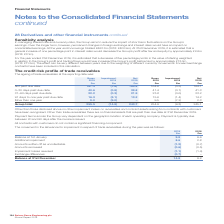According to Spirax Sarco Engineering Plc's financial document, How do payment terms across the Group vary? dependent on the geographic location of each operating company. The document states: "Payment terms across the Group vary dependent on the geographic location of each operating company. Payment is typically due between 20 and 90 days af..." Also, When is payment typically due for trade receivables? between 20 and 90 days after the invoice is issued. The document states: "each operating company. Payment is typically due between 20 and 90 days after the invoice is issued...." Also, For which years was the movement in the allowance for impairment in respect of trade receivables during the year recorded? The document shows two values: 2019 and 2018. From the document: "Spirax-Sarco Engineering plc Annual Report 2019 ngs. At the year end borrowings totalled £463.7m (2018: £422.9m). At 31st December 2019, it is estimat..." Additionally, In which year was the balance at 1st January larger? According to the financial document, 2019. The relevant text states: "Spirax-Sarco Engineering plc Annual Report 2019..." Also, can you calculate: What was the change in the balance at 31st December in 2019 from 2018? Based on the calculation: 14.8-9.8, the result is 5 (in millions). This is based on the information: "2018 £m Balance at 1st January 9.8 9.6 Additional impairment 8.6 2.8 Amounts written off as uncollectable (1.2) (0.7) Amounts recovere ange differences (0.7) – Balance at 31st December 14.8 9.8..." The key data points involved are: 14.8, 9.8. Also, can you calculate: What was the percentage change in the balance at 31st December in 2019 from 2018? To answer this question, I need to perform calculations using the financial data. The calculation is: (14.8-9.8)/9.8, which equals 51.02 (percentage). This is based on the information: "2018 £m Balance at 1st January 9.8 9.6 Additional impairment 8.6 2.8 Amounts written off as uncollectable (1.2) (0.7) Amounts recovere ange differences (0.7) – Balance at 31st December 14.8 9.8..." The key data points involved are: 14.8, 9.8. 